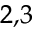<formula> <loc_0><loc_0><loc_500><loc_500>^ { 2 , 3 }</formula> 